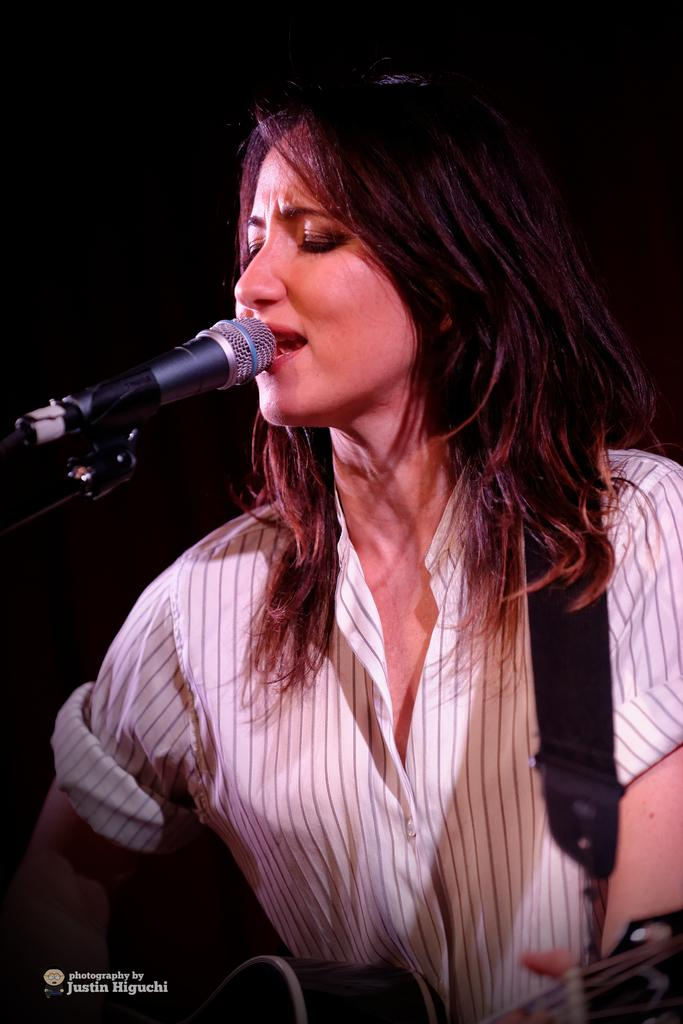Who is the main subject in the image? There is a woman in the image. What is the woman holding in the image? The woman is holding a guitar. What is the woman doing in the image? The woman is singing. What object is present for amplifying her voice? There is a microphone in the image. How would you describe the lighting in the image? The background of the image appears dark. Can you see a river flowing in the background of the image? There is no river visible in the image; the background appears dark. 